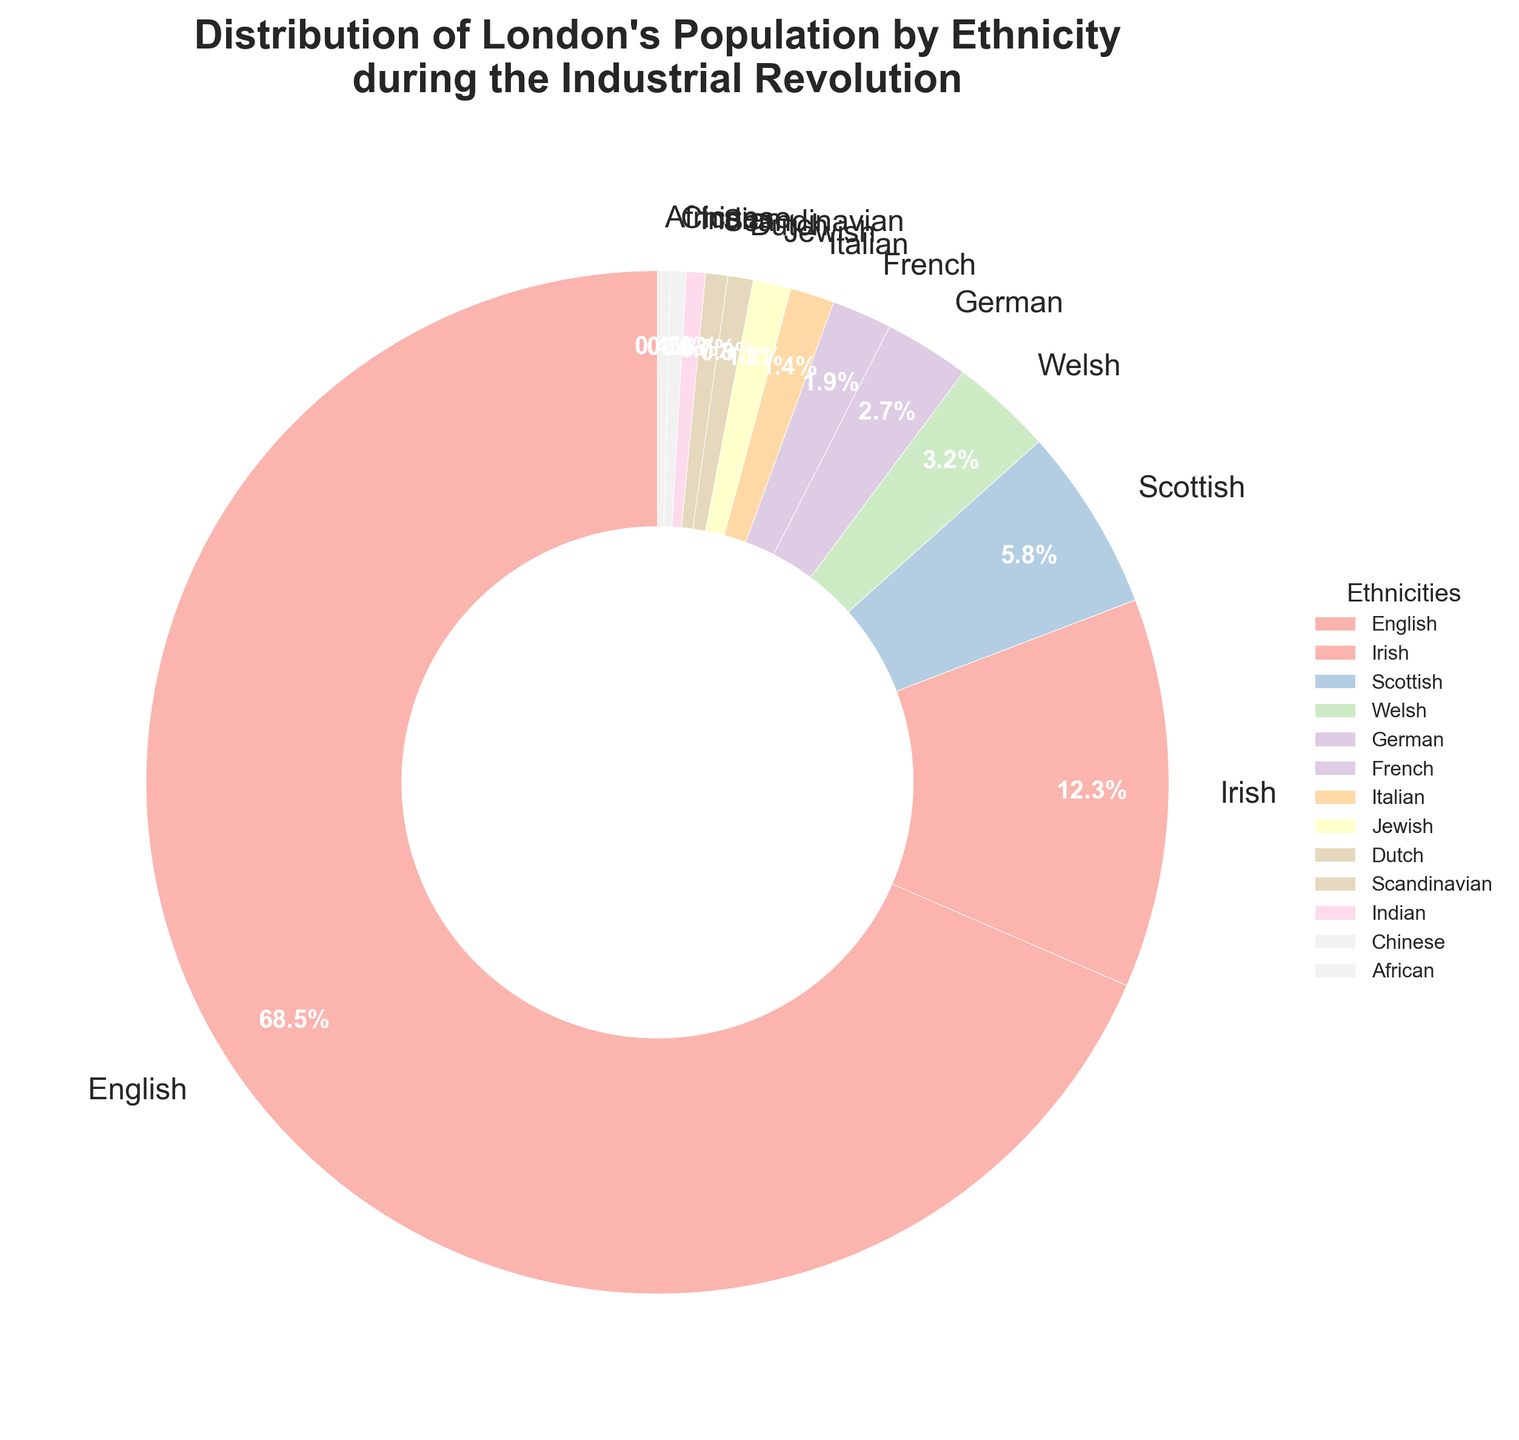What is the largest ethnic group represented in the pie chart? The largest segment of the pie chart is labeled "English" and constitutes 68.5% of the population, surpassing any other group's percentage.
Answer: English How much greater is the percentage of the Irish population compared to the German population? The percentage of the Irish population is 12.3%, and the percentage of the German population is 2.7%. The difference is calculated by subtracting the German percentage from the Irish percentage: 12.3% - 2.7% = 9.6%.
Answer: 9.6% What is the total percentage of the population made up by Scottish, Welsh, and French ethnicities combined? Adding the percentages for Scottish (5.8%), Welsh (3.2%), and French (1.9%) gives the total: 5.8% + 3.2% + 1.9% = 10.9%.
Answer: 10.9% Which ethnic group has a slightly larger representation, Italian or Jewish? The percentage for the Italian population is 1.4%, and for the Jewish population, it is 1.2%. Since 1.4% is greater than 1.2%, the Italian population has a slightly larger representation.
Answer: Italian What is the combined percentage of the three smallest ethnic groups represented? The smallest percentages are for Chinese (0.5%), African (0.4%), and Dutch (0.8%) populations. Adding these together gives: 0.5% + 0.4% + 0.8% = 1.7%.
Answer: 1.7% What is the average percentage of the English, Irish, and Scottish populations? The percentages of the English, Irish, and Scottish populations are 68.5%, 12.3%, and 5.8% respectively. The sum of these percentages is 68.5% + 12.3% + 5.8% = 86.6%. Dividing by 3 to get the average: 86.6% / 3 ≈ 28.87%.
Answer: 28.87% Is the Welsh population represented by a larger or smaller percentage than the Italian population? The Welsh population is represented by 3.2%, while the Italian population is represented by 1.4%. Since 3.2% > 1.4%, the Welsh population is represented by a larger percentage.
Answer: Larger What is the difference between the combined percentage of German and French populations and the combined percentage of Italian and Jewish populations? The percentages are: German 2.7%, French 1.9%, Italian 1.4%, and Jewish 1.2%. First, the sum for German and French: 2.7% + 1.9% = 4.6%. Then, the sum for Italian and Jewish: 1.4% + 1.2% = 2.6%. The difference: 4.6% - 2.6% = 2.0%.
Answer: 2.0% 